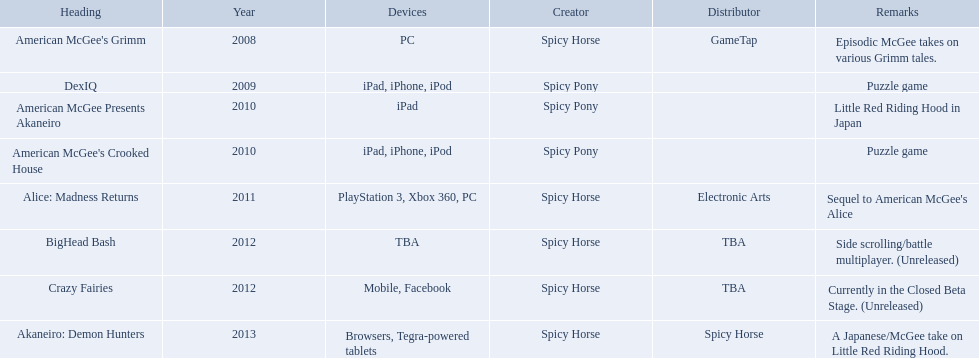What year had a total of 2 titles released? 2010. 